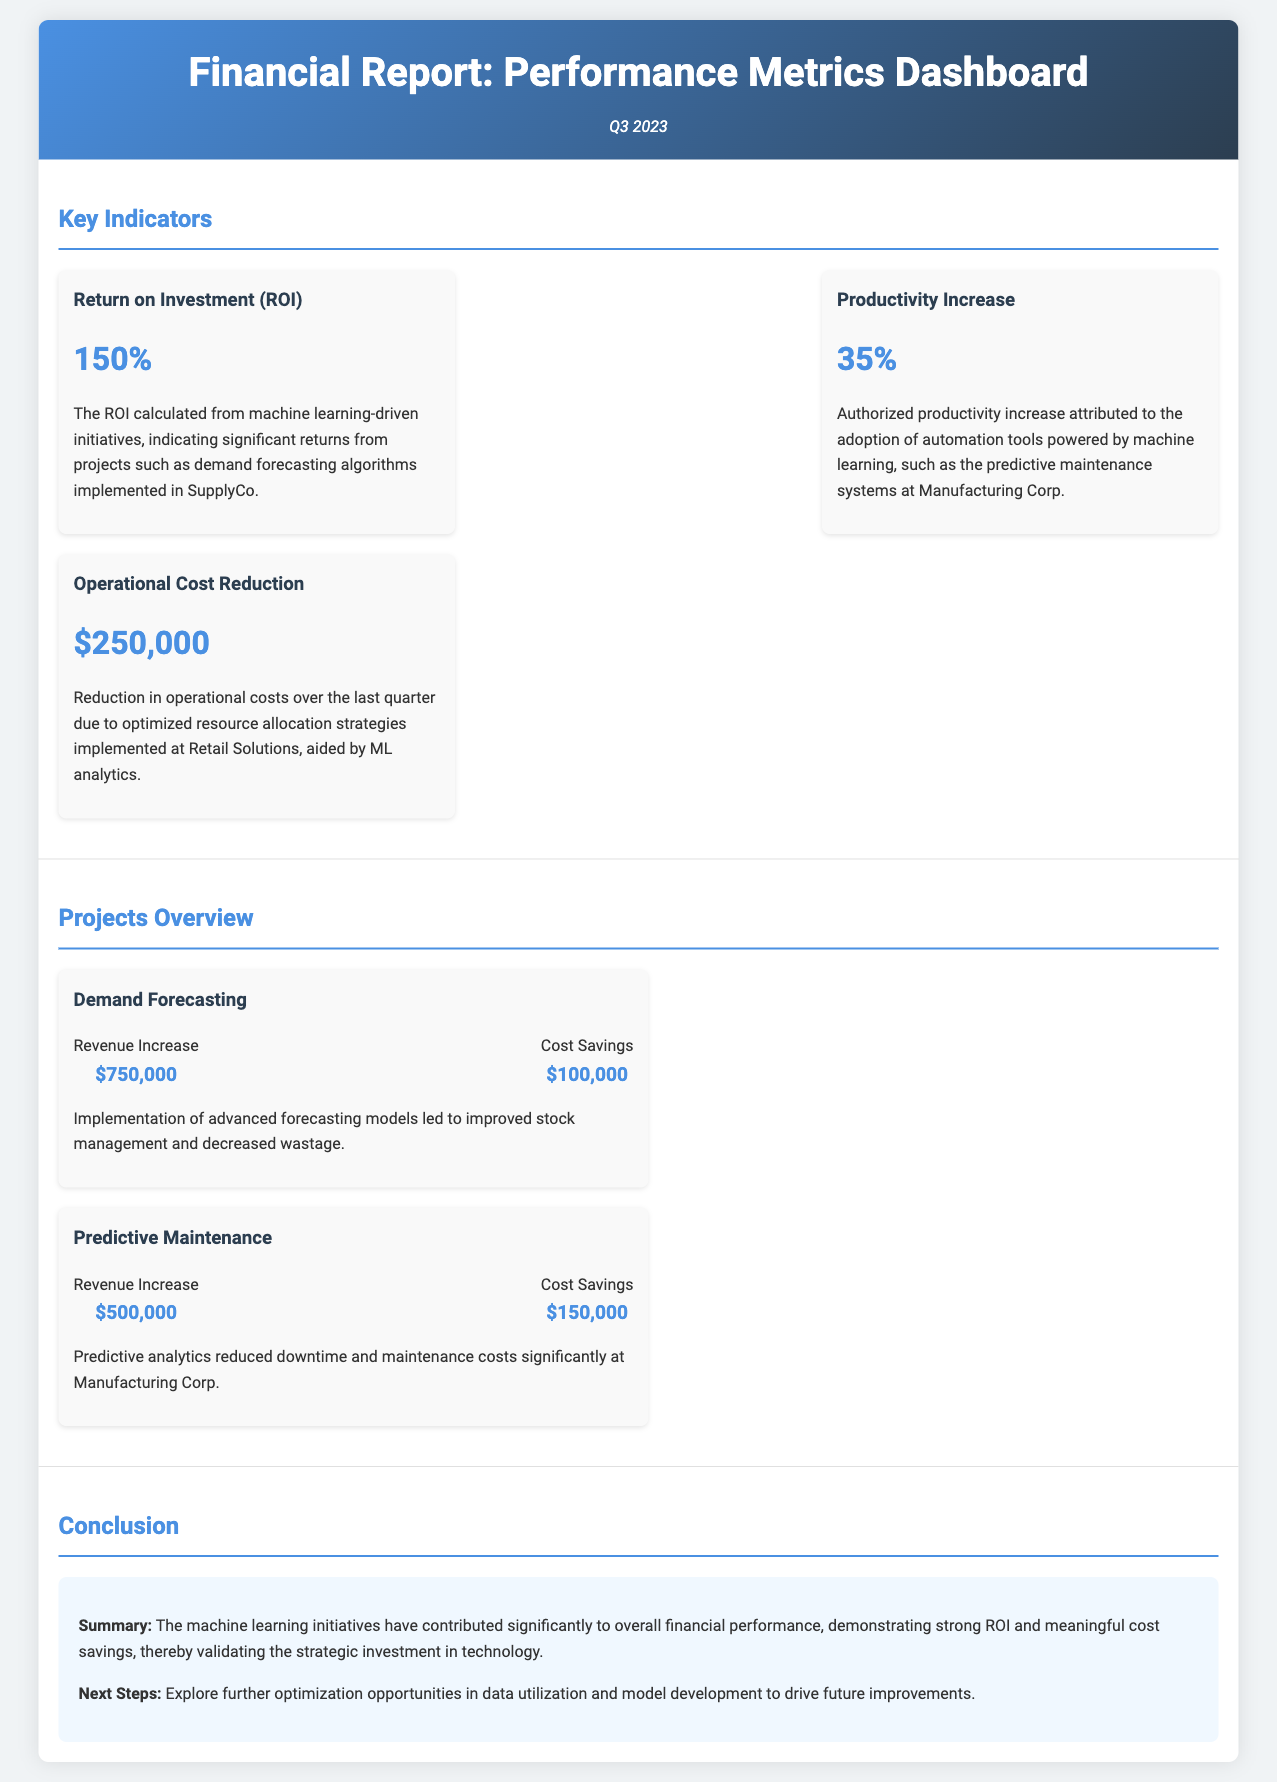What is the Return on Investment (ROI)? The ROI shown in the document represents the financial return from machine learning-driven initiatives, stated as 150%.
Answer: 150% What was the productivity increase percentage? The document states that the authorized productivity increase attributed to machine learning is 35%.
Answer: 35% How much was the operational cost reduction over the last quarter? The operational cost reduction mentioned in the document amounts to $250,000.
Answer: $250,000 What is the revenue increase from the Demand Forecasting project? The financial impact of the Demand Forecasting project includes a revenue increase of $750,000.
Answer: $750,000 What are the next steps suggested in the conclusion? The document suggests exploring further optimization opportunities in data utilization and model development.
Answer: Explore further optimization opportunities What was the total revenue increase from both projects mentioned? The total revenue increase is calculated by adding the revenue increases from both projects: $750,000 + $500,000.
Answer: $1,250,000 What financial impact did the Predictive Maintenance project achieve in cost savings? The cost savings achieved by the Predictive Maintenance project is stated as $150,000.
Answer: $150,000 What quarter does this financial report cover? The report details relate to Q3 2023 as indicated at the top of the document.
Answer: Q3 2023 What is the main conclusion of the financial report? The conclusion of the report emphasizes that the machine learning initiatives have significantly contributed to overall financial performance.
Answer: Significant contribution to overall financial performance 